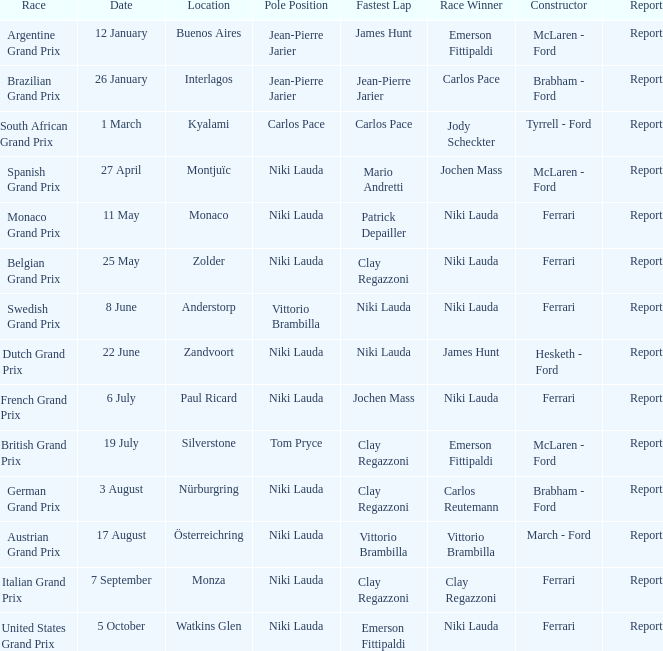Which race featured tom pryce's team in the pole position? Silverstone. 